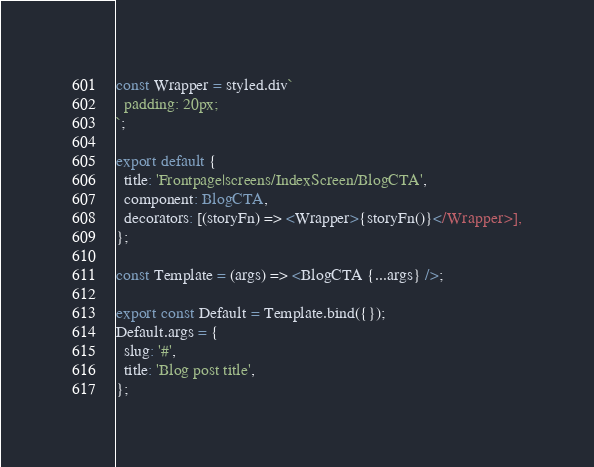<code> <loc_0><loc_0><loc_500><loc_500><_TypeScript_>
const Wrapper = styled.div`
  padding: 20px;
`;

export default {
  title: 'Frontpage|screens/IndexScreen/BlogCTA',
  component: BlogCTA,
  decorators: [(storyFn) => <Wrapper>{storyFn()}</Wrapper>],
};

const Template = (args) => <BlogCTA {...args} />;

export const Default = Template.bind({});
Default.args = {
  slug: '#',
  title: 'Blog post title',
};
</code> 